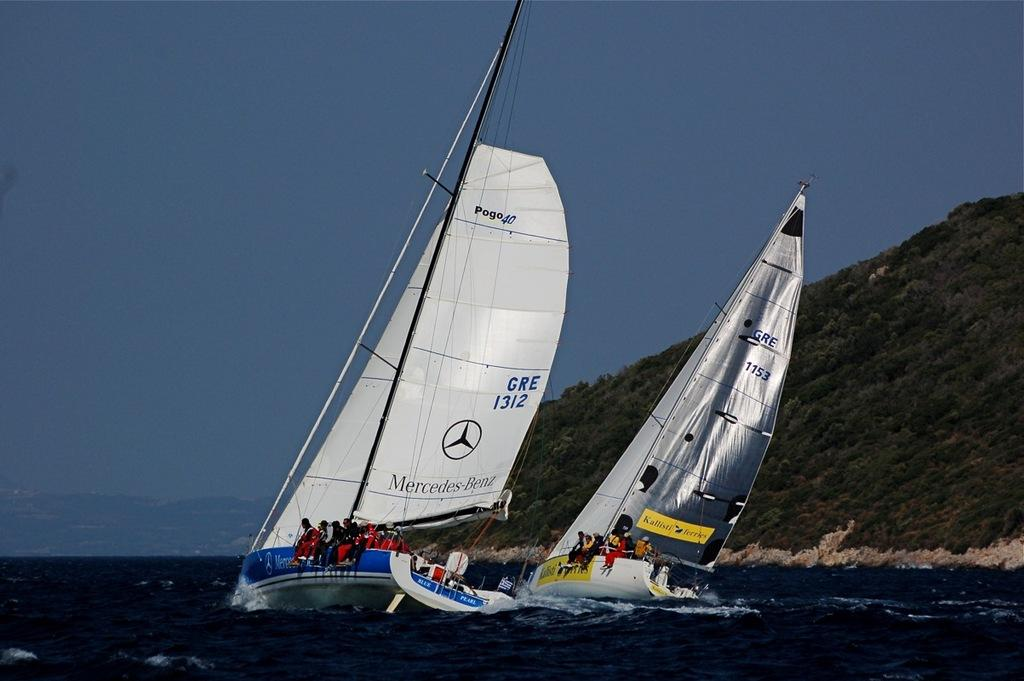<image>
Offer a succinct explanation of the picture presented. Two sailboats full of people sailing in the water one of them has gre 1312 on the sail. 